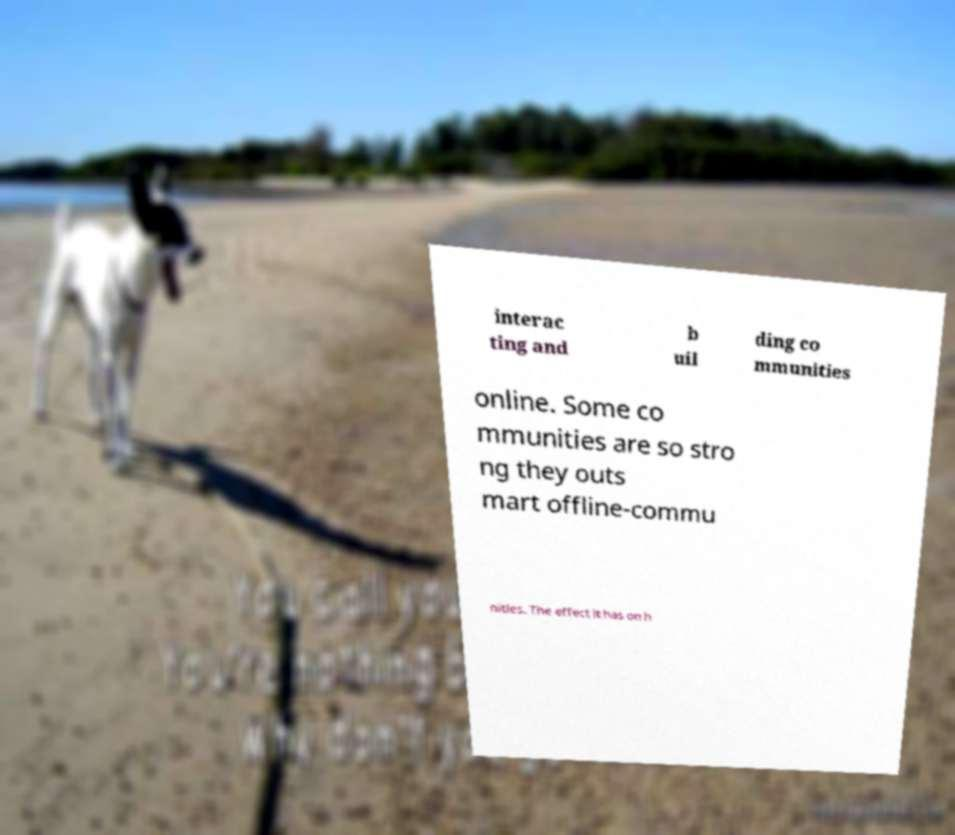Please read and relay the text visible in this image. What does it say? interac ting and b uil ding co mmunities online. Some co mmunities are so stro ng they outs mart offline-commu nities. The effect it has on h 